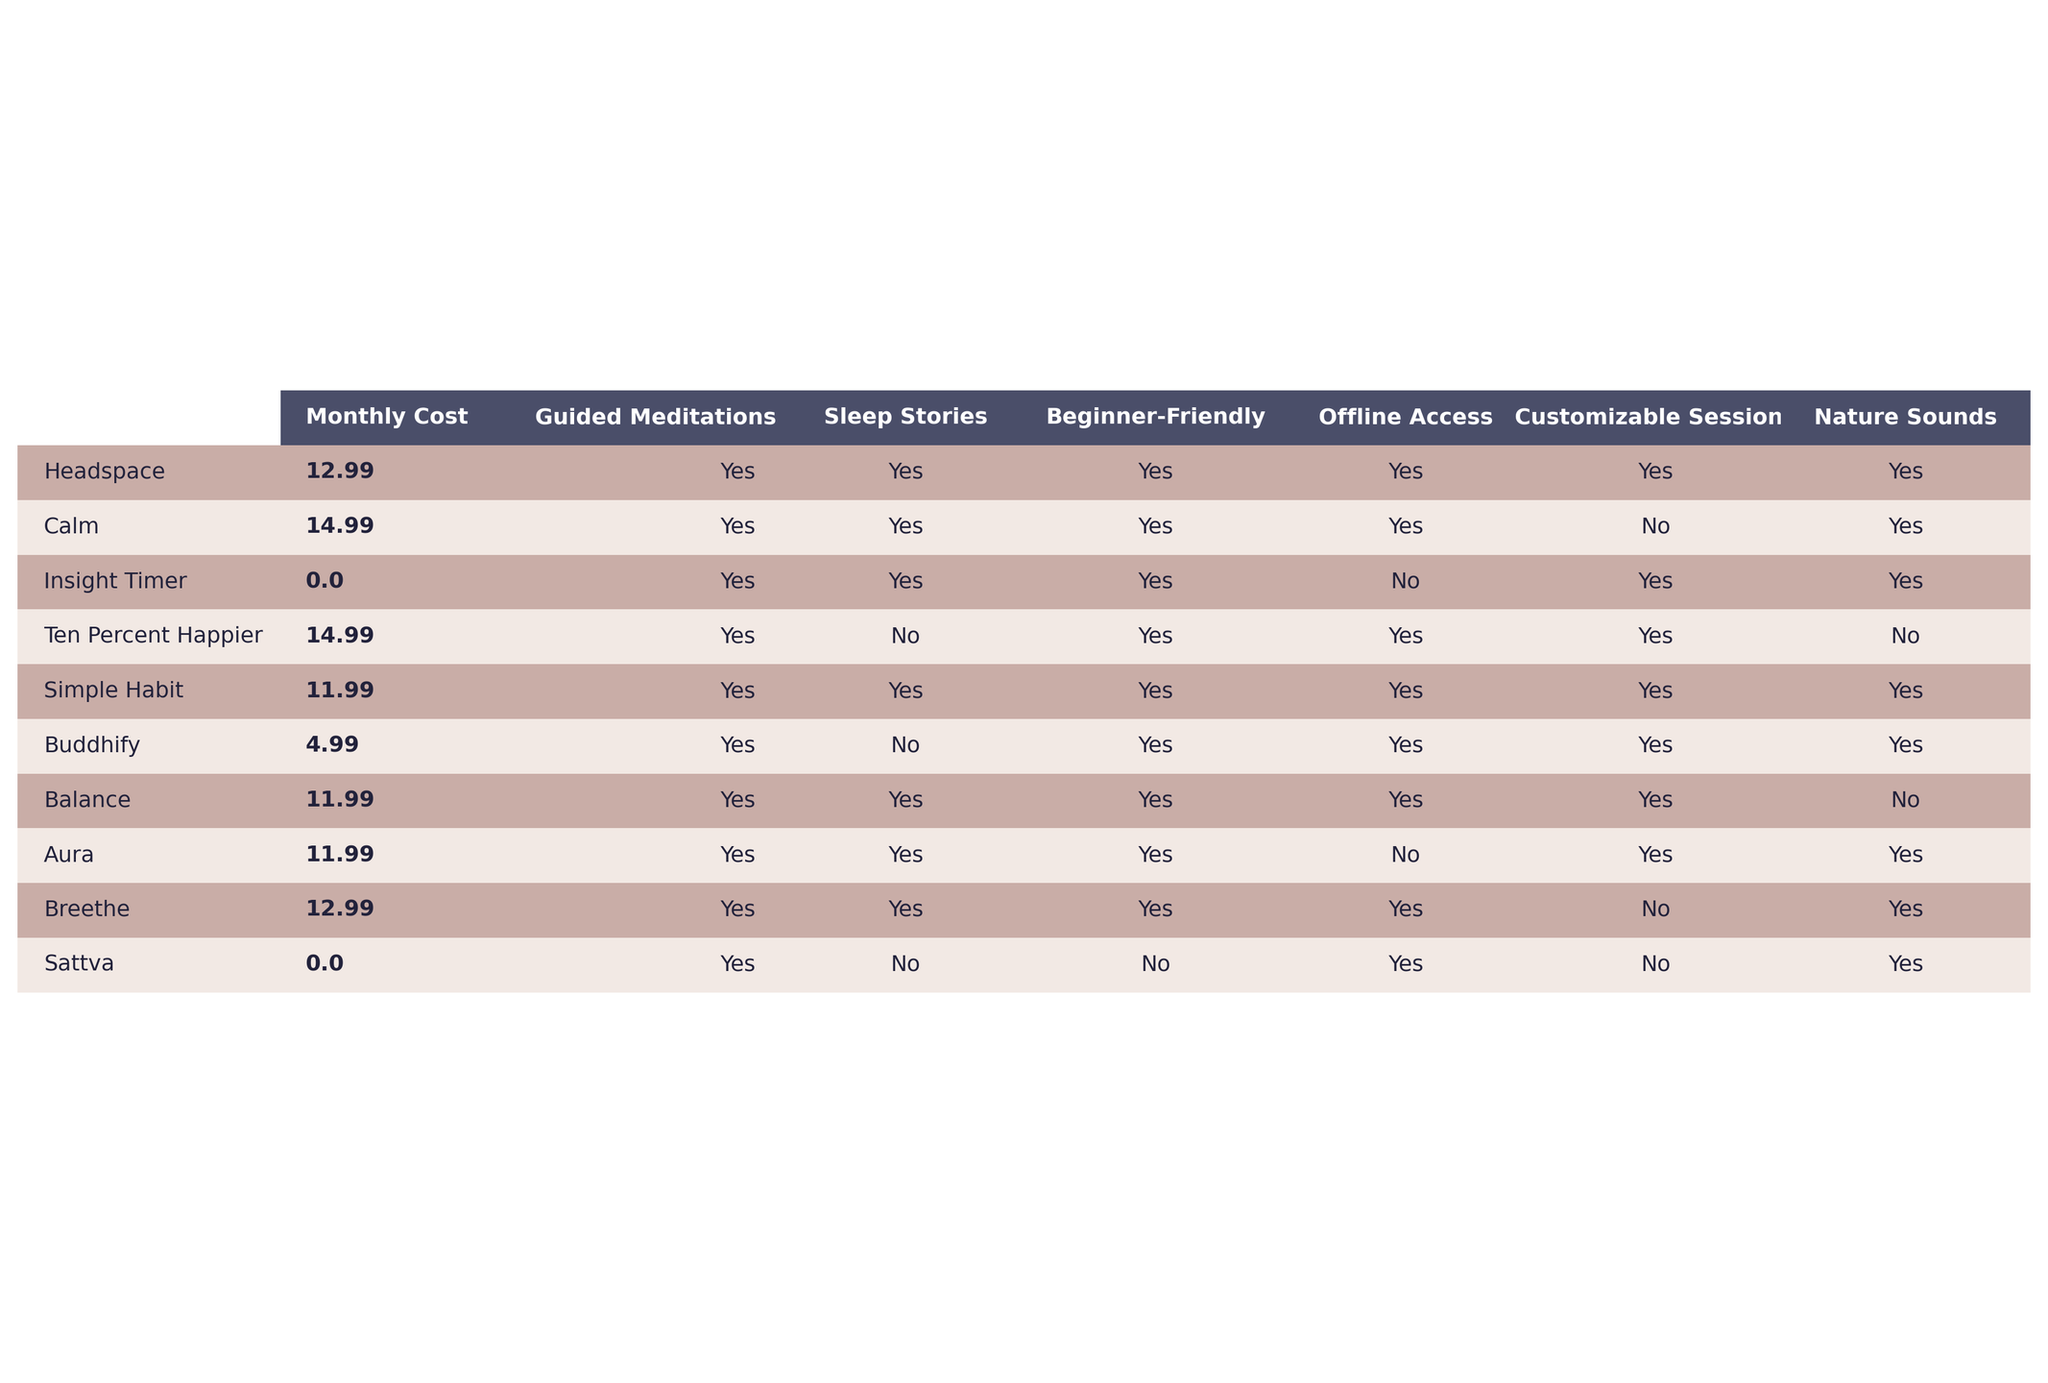What is the monthly cost of Headspace? In the table, the monthly cost of Headspace is listed directly next to its name. It shows "$12.99".
Answer: $12.99 Which app offers free access? The table indicates that the "Insight Timer" and "Sattva" apps are marked as "Free" under the Monthly Cost column.
Answer: Insight Timer and Sattva How many apps provide sleep stories? By counting the "Yes" responses in the Sleep Stories column, we find that 7 out of the 10 apps offer this feature.
Answer: 7 Which app is the cheapest, and what is its price? Looking at the Monthly Cost, we see that Buddhify offers the lowest cost at "$4.99".
Answer: Buddhify, $4.99 How many apps offer offline access? By checking the Offline Access column for "Yes," we find that there are 6 apps that provide this option.
Answer: 6 What is the average monthly cost of the apps that have offline access? The apps with offline access and their costs are: Headspace ($12.99), Calm ($14.99), Ten Percent Happier ($14.99), Simple Habit ($11.99), Balance ($11.99), and Breethe ($12.99). Adding these together gives $12.99 + $14.99 + $14.99 + $11.99 + $11.99 + $12.99 = $79.94. Dividing by 6 apps gives an average of $79.94 / 6 ≈ $13.32.
Answer: $13.32 Which app does not have customizable sessions, but provides guided meditations? Looking at the Customizable Sessions column and the Guided Meditations column, we see that Calm and Breethe have "No" under Customizable Sessions but "Yes" under Guided Meditations, which meets the criteria.
Answer: Calm and Breethe How many apps are beginner-friendly and also provide nature sounds? We can identify from the table that the apps which are both "Yes" for Beginner-Friendly and "Yes" for Nature Sounds are: Headspace, Insight Timer, Simple Habit, and Buddhify. That totals 4 apps.
Answer: 4 What is the total number of unique features offered by the app Calm compared to Headspace? Examining both Calm and Headspace, we see that Calm offers Guided Meditations, Sleep Stories, Beginner-Friendly, and Offline Access (4 features), while Headspace has all of these plus Customizable Sessions and Nature Sounds (6 features). The unique features for Headspace compared to Calm are 2.
Answer: 2 Which app has the highest number of features? By counting each of the "Yes" responses for the capabilities listed, we see that Headspace has all features marked as "Yes," resulting in 6 features. No other app can achieve this, so Headspace has the most.
Answer: Headspace Is there an app that offers beginner-friendly features but does not include sleep stories? Looking through the table, we find that Ten Percent Happier and Sattva are both marked as "Yes" for Beginner-Friendly but "No" for Sleep Stories, fitting the criteria.
Answer: Ten Percent Happier and Sattva 